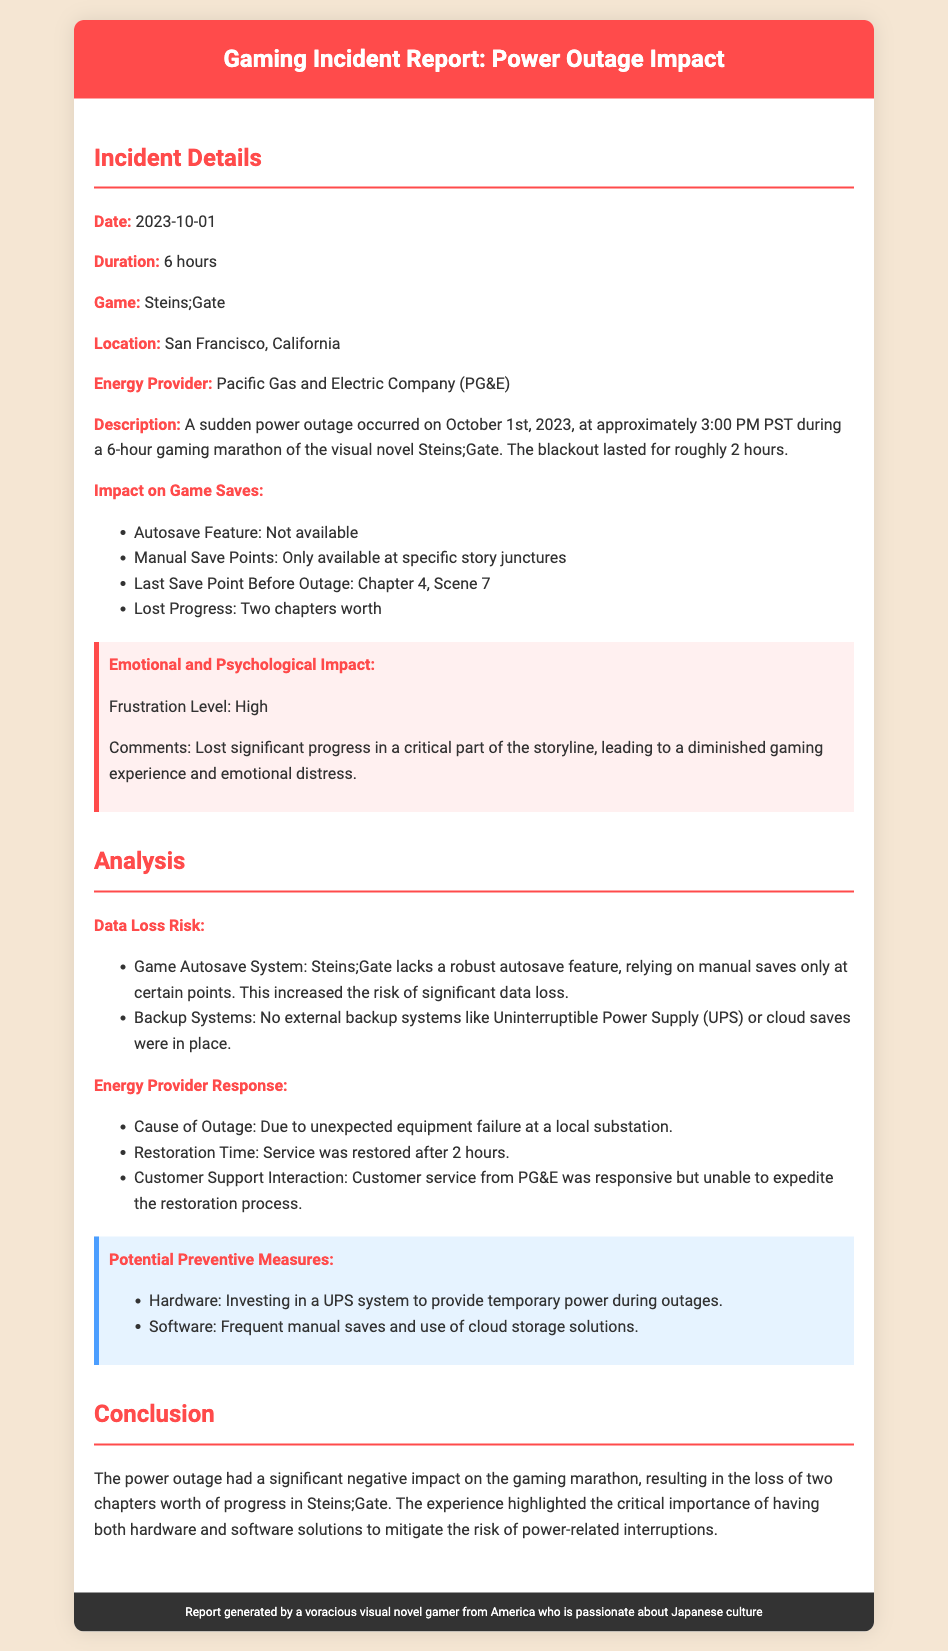what was the date of the incident? The document states that the incident occurred on October 1st, 2023.
Answer: October 1st, 2023 how long did the power outage last? The report mentions that the power outage lasted for roughly 2 hours.
Answer: 2 hours which game was being played during the outage? The incident report specifies that the game being played was Steins;Gate.
Answer: Steins;Gate what was the last save point before the outage? It is mentioned that the last save point before the outage was at Chapter 4, Scene 7.
Answer: Chapter 4, Scene 7 what was the frustration level reported? The report indicates that the frustration level was high.
Answer: High what is one potential preventive measure suggested in the report? The document recommends investing in a UPS system to provide temporary power during outages.
Answer: UPS system what caused the power outage? The report clarifies that the cause of the outage was unexpected equipment failure at a local substation.
Answer: Equipment failure at a local substation how many chapters worth of progress were lost? The document specifies that two chapters worth of progress were lost.
Answer: Two chapters what was the emotional impact of losing progress? The report notes emotional and psychological impact, specifying it as frustration leading to diminished gaming experience.
Answer: Frustration 